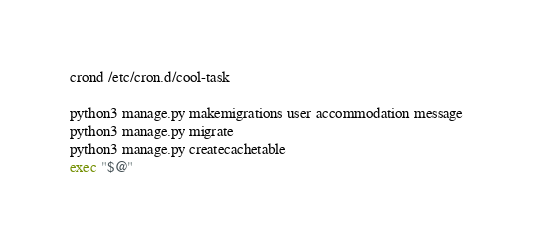Convert code to text. <code><loc_0><loc_0><loc_500><loc_500><_Bash_>crond /etc/cron.d/cool-task

python3 manage.py makemigrations user accommodation message
python3 manage.py migrate
python3 manage.py createcachetable
exec "$@"</code> 